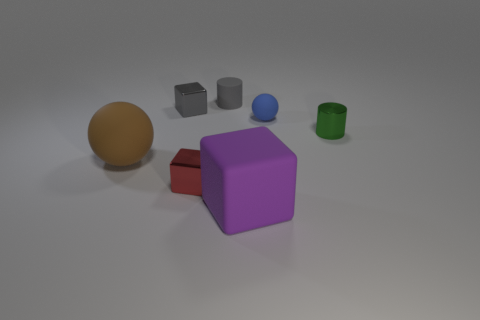Add 1 gray rubber cylinders. How many objects exist? 8 Subtract all cubes. How many objects are left? 4 Add 1 purple matte blocks. How many purple matte blocks are left? 2 Add 5 big purple blocks. How many big purple blocks exist? 6 Subtract 0 green cubes. How many objects are left? 7 Subtract all big cyan cubes. Subtract all gray objects. How many objects are left? 5 